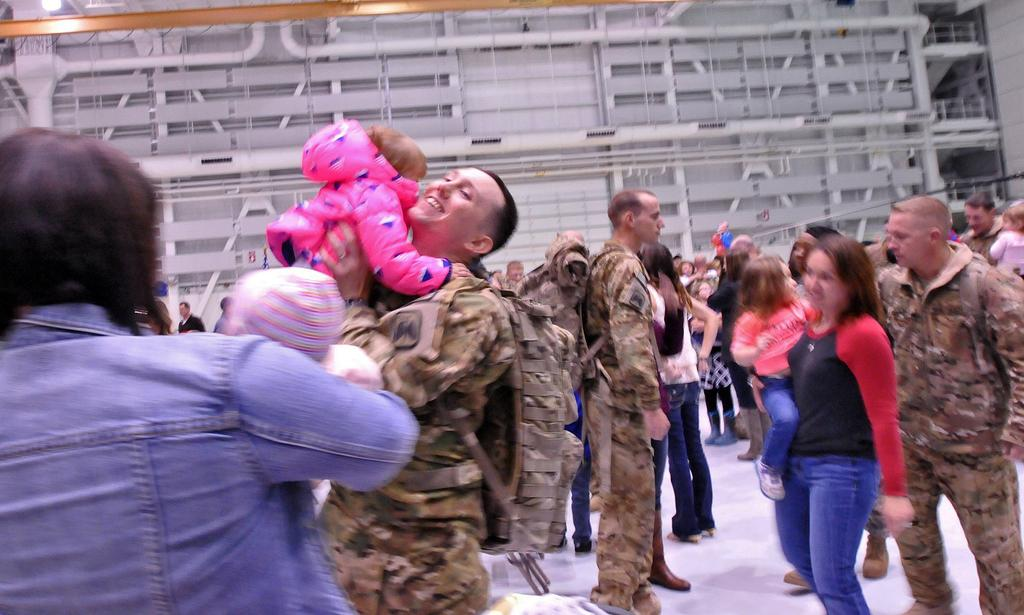How many people are in the group in the image? There is a group of people in the image, but the exact number is not specified. What are some people in the group doing? Some people in the group are carrying children. Where are the people standing in the image? The people are standing on the floor. What can be seen in the background of the image? There is a wall with pipes visible in the background of the image. What type of haircut is being offered to the children in the image? There is no indication in the image that a haircut is being offered to the children or anyone else. 